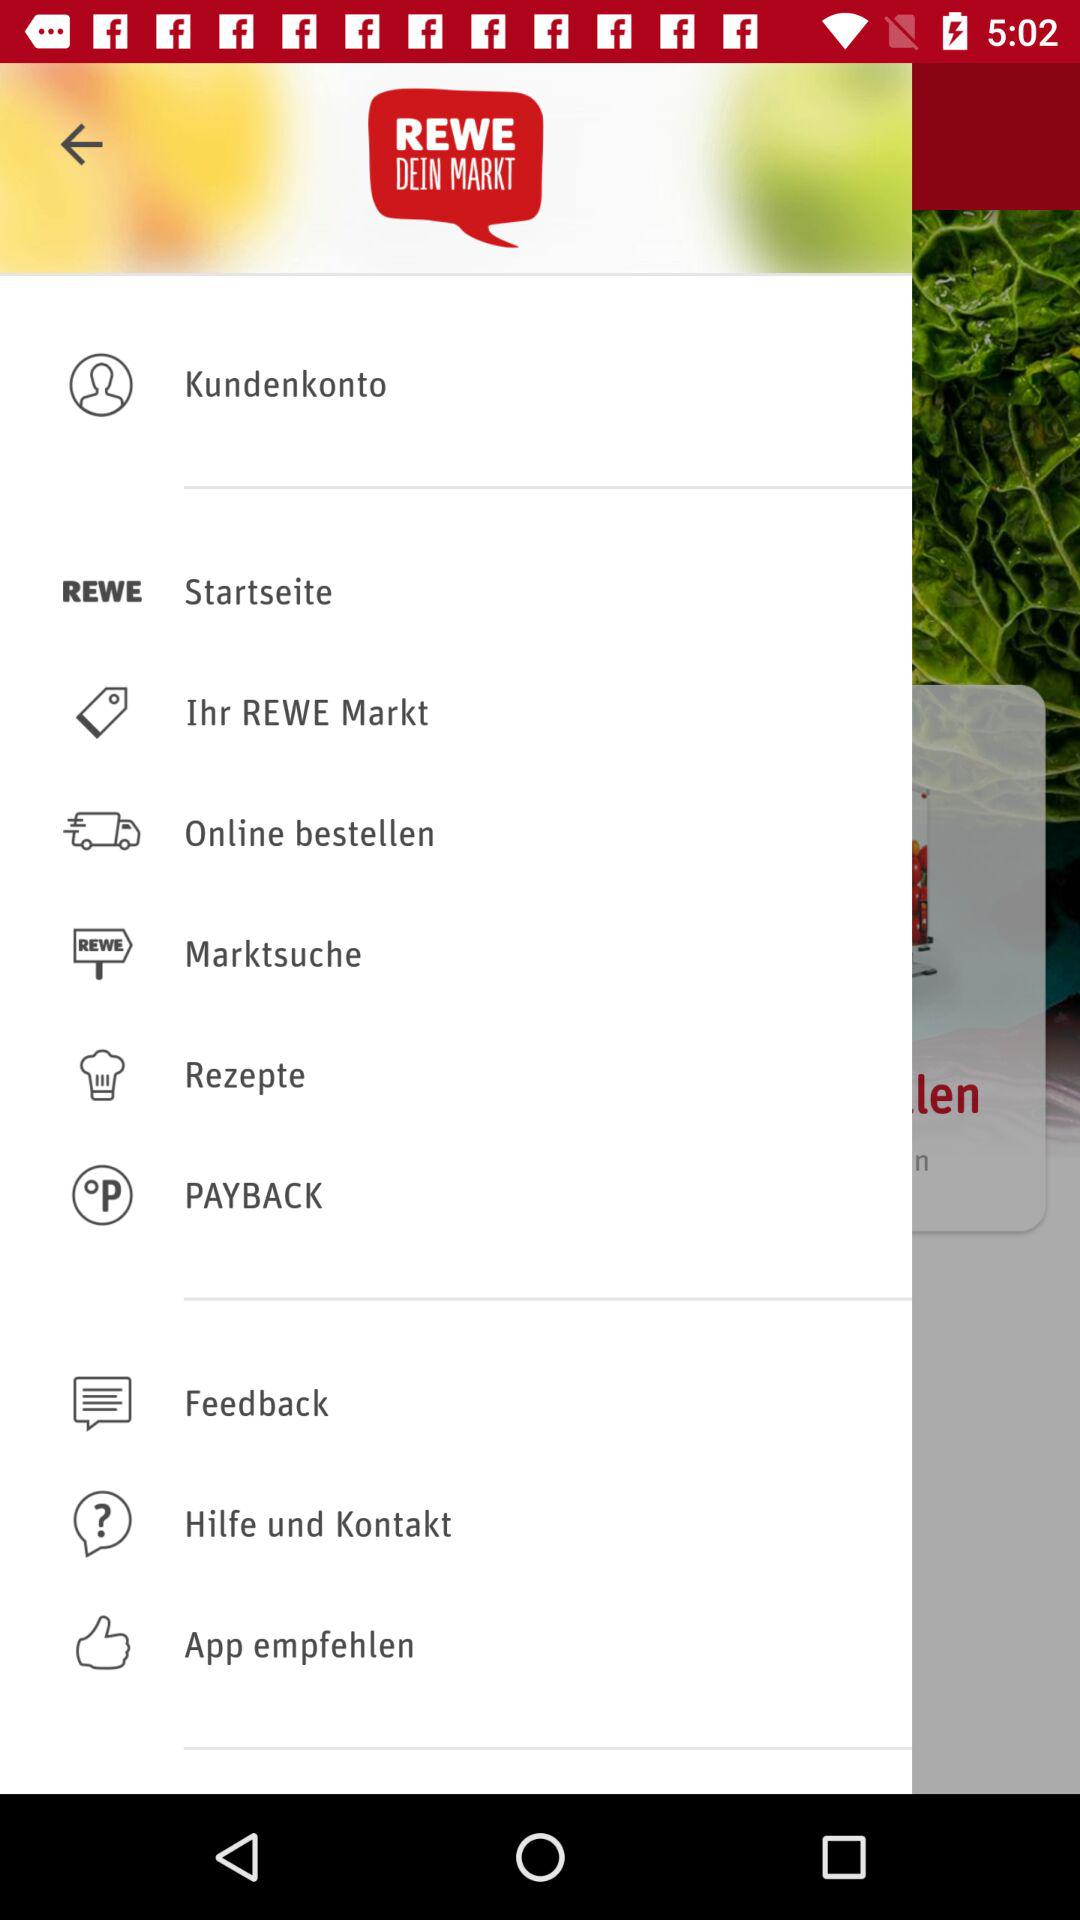What is the name of the user? The name of the user is "Kundenkonto". 